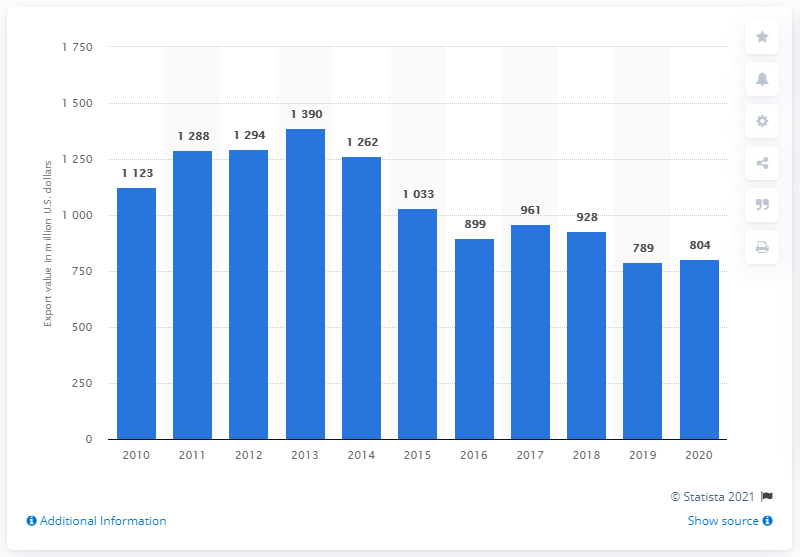Indicate a few pertinent items in this graphic. In 2019, American textile and apparel exports declined by 78.9%. In 2020, the value of U.S. textile and apparel exports to China was $804 million. 